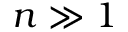<formula> <loc_0><loc_0><loc_500><loc_500>n \gg 1</formula> 